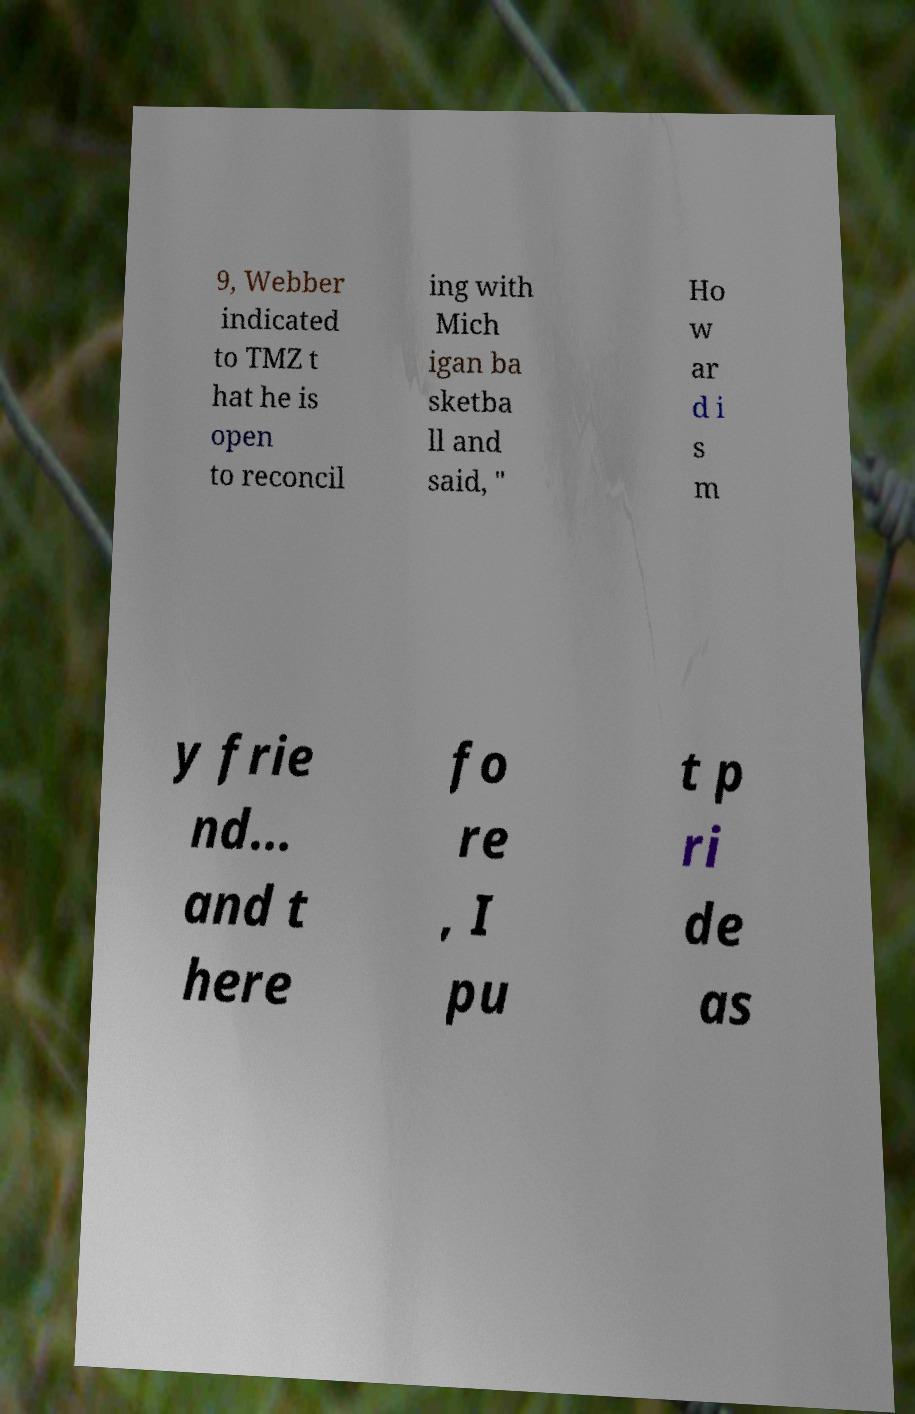There's text embedded in this image that I need extracted. Can you transcribe it verbatim? 9, Webber indicated to TMZ t hat he is open to reconcil ing with Mich igan ba sketba ll and said, " Ho w ar d i s m y frie nd... and t here fo re , I pu t p ri de as 